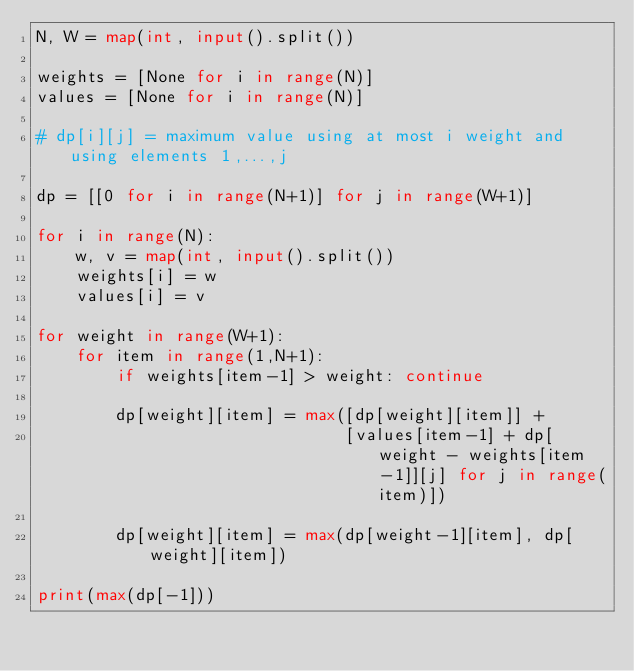Convert code to text. <code><loc_0><loc_0><loc_500><loc_500><_Python_>N, W = map(int, input().split())

weights = [None for i in range(N)]
values = [None for i in range(N)]

# dp[i][j] = maximum value using at most i weight and using elements 1,...,j

dp = [[0 for i in range(N+1)] for j in range(W+1)]

for i in range(N):
    w, v = map(int, input().split())
    weights[i] = w
    values[i] = v
    
for weight in range(W+1):
    for item in range(1,N+1):
        if weights[item-1] > weight: continue

        dp[weight][item] = max([dp[weight][item]] + 
                               [values[item-1] + dp[weight - weights[item-1]][j] for j in range(item)])

        dp[weight][item] = max(dp[weight-1][item], dp[weight][item])
    
print(max(dp[-1]))
</code> 